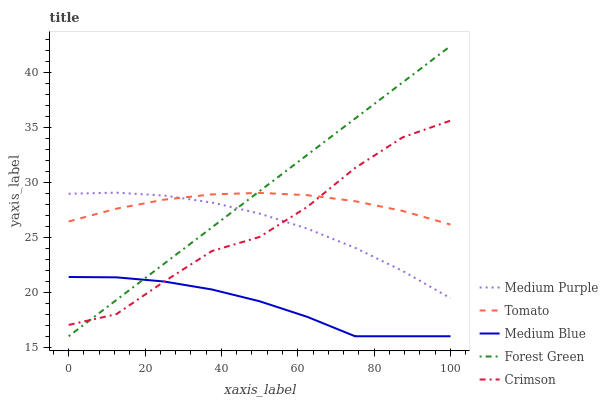Does Medium Blue have the minimum area under the curve?
Answer yes or no. Yes. Does Forest Green have the maximum area under the curve?
Answer yes or no. Yes. Does Tomato have the minimum area under the curve?
Answer yes or no. No. Does Tomato have the maximum area under the curve?
Answer yes or no. No. Is Forest Green the smoothest?
Answer yes or no. Yes. Is Crimson the roughest?
Answer yes or no. Yes. Is Tomato the smoothest?
Answer yes or no. No. Is Tomato the roughest?
Answer yes or no. No. Does Tomato have the lowest value?
Answer yes or no. No. Does Forest Green have the highest value?
Answer yes or no. Yes. Does Tomato have the highest value?
Answer yes or no. No. Is Medium Blue less than Tomato?
Answer yes or no. Yes. Is Tomato greater than Medium Blue?
Answer yes or no. Yes. Does Medium Blue intersect Tomato?
Answer yes or no. No. 